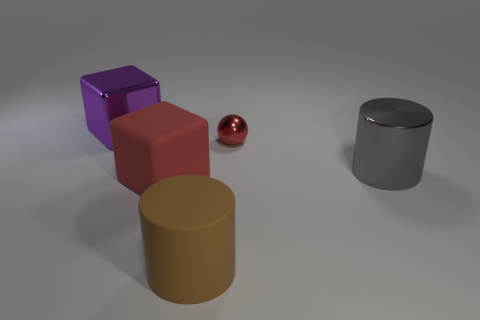Does the gray object have the same size as the sphere?
Offer a terse response. No. Is there anything else that has the same size as the red metallic ball?
Give a very brief answer. No. How many other things are there of the same color as the rubber block?
Keep it short and to the point. 1. Do the large brown thing and the block that is in front of the big purple cube have the same material?
Provide a succinct answer. Yes. Is the number of big cylinders in front of the gray metal cylinder greater than the number of matte things that are in front of the matte cube?
Make the answer very short. No. The rubber thing behind the large matte object in front of the red rubber block is what color?
Provide a succinct answer. Red. What number of cylinders are tiny brown metallic objects or gray things?
Provide a succinct answer. 1. What number of blocks are both behind the large red object and in front of the large purple shiny object?
Keep it short and to the point. 0. There is a large thing that is behind the gray object; what is its color?
Your answer should be compact. Purple. There is a gray cylinder that is made of the same material as the small ball; what size is it?
Offer a terse response. Large. 